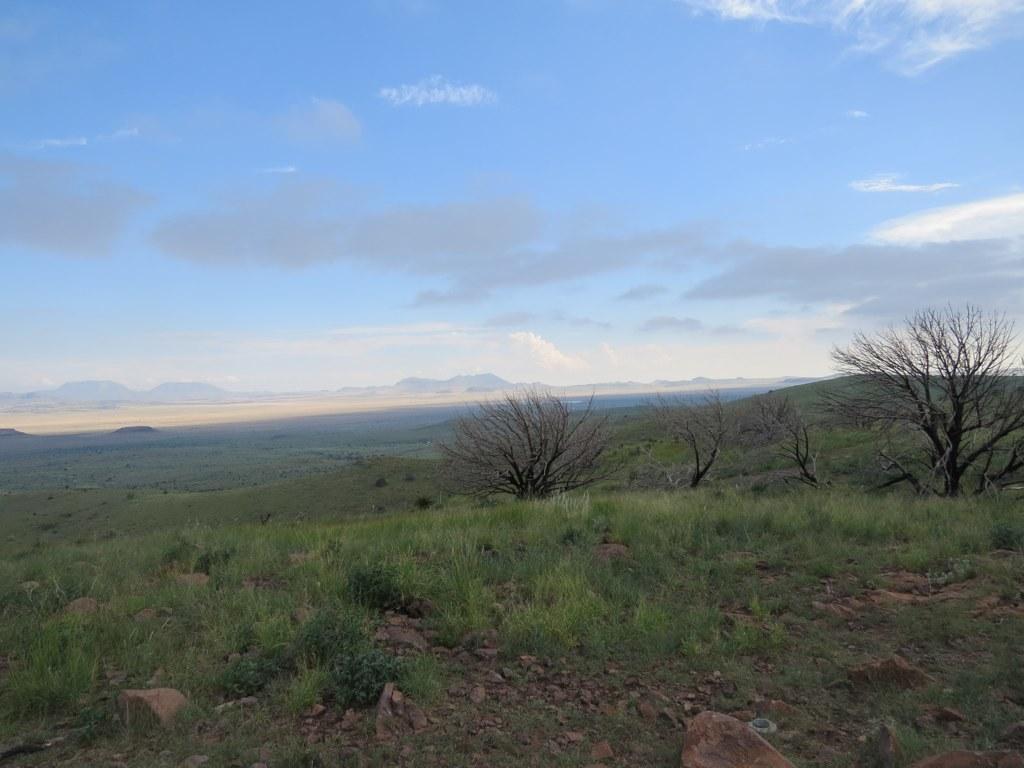Can you describe this image briefly? At the bottom of the image there is grass,stones. In the background of the image there are mountains,trees,sky and clouds. 